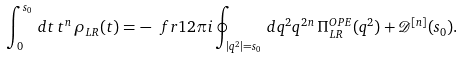<formula> <loc_0><loc_0><loc_500><loc_500>\int _ { 0 } ^ { s _ { 0 } } \, d t \, t ^ { n } \, \rho _ { L R } ( t ) = - \ f r { 1 } { 2 \pi i } \oint _ { | q ^ { 2 } | = s _ { 0 } } \, d q ^ { 2 } q ^ { 2 n } \, \Pi _ { L R } ^ { O P E } ( q ^ { 2 } ) + { \mathcal { D } } ^ { [ n ] } ( s _ { 0 } ) .</formula> 